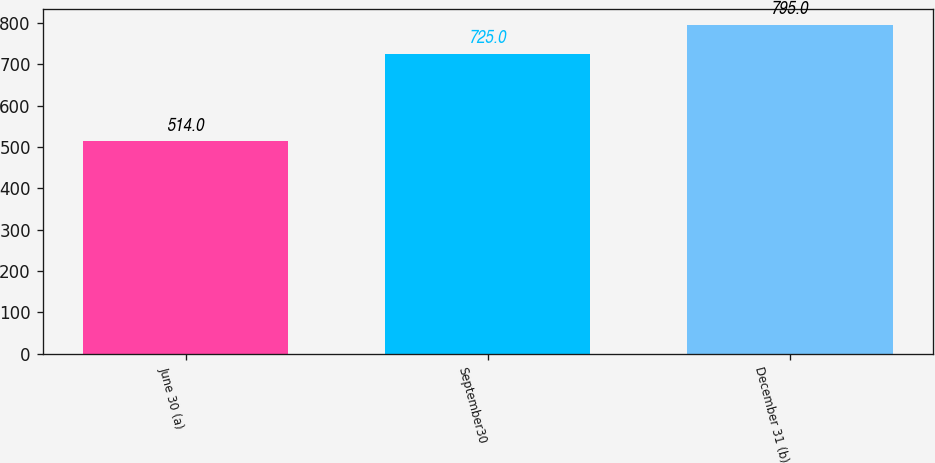Convert chart. <chart><loc_0><loc_0><loc_500><loc_500><bar_chart><fcel>June 30 (a)<fcel>September30<fcel>December 31 (b)<nl><fcel>514<fcel>725<fcel>795<nl></chart> 